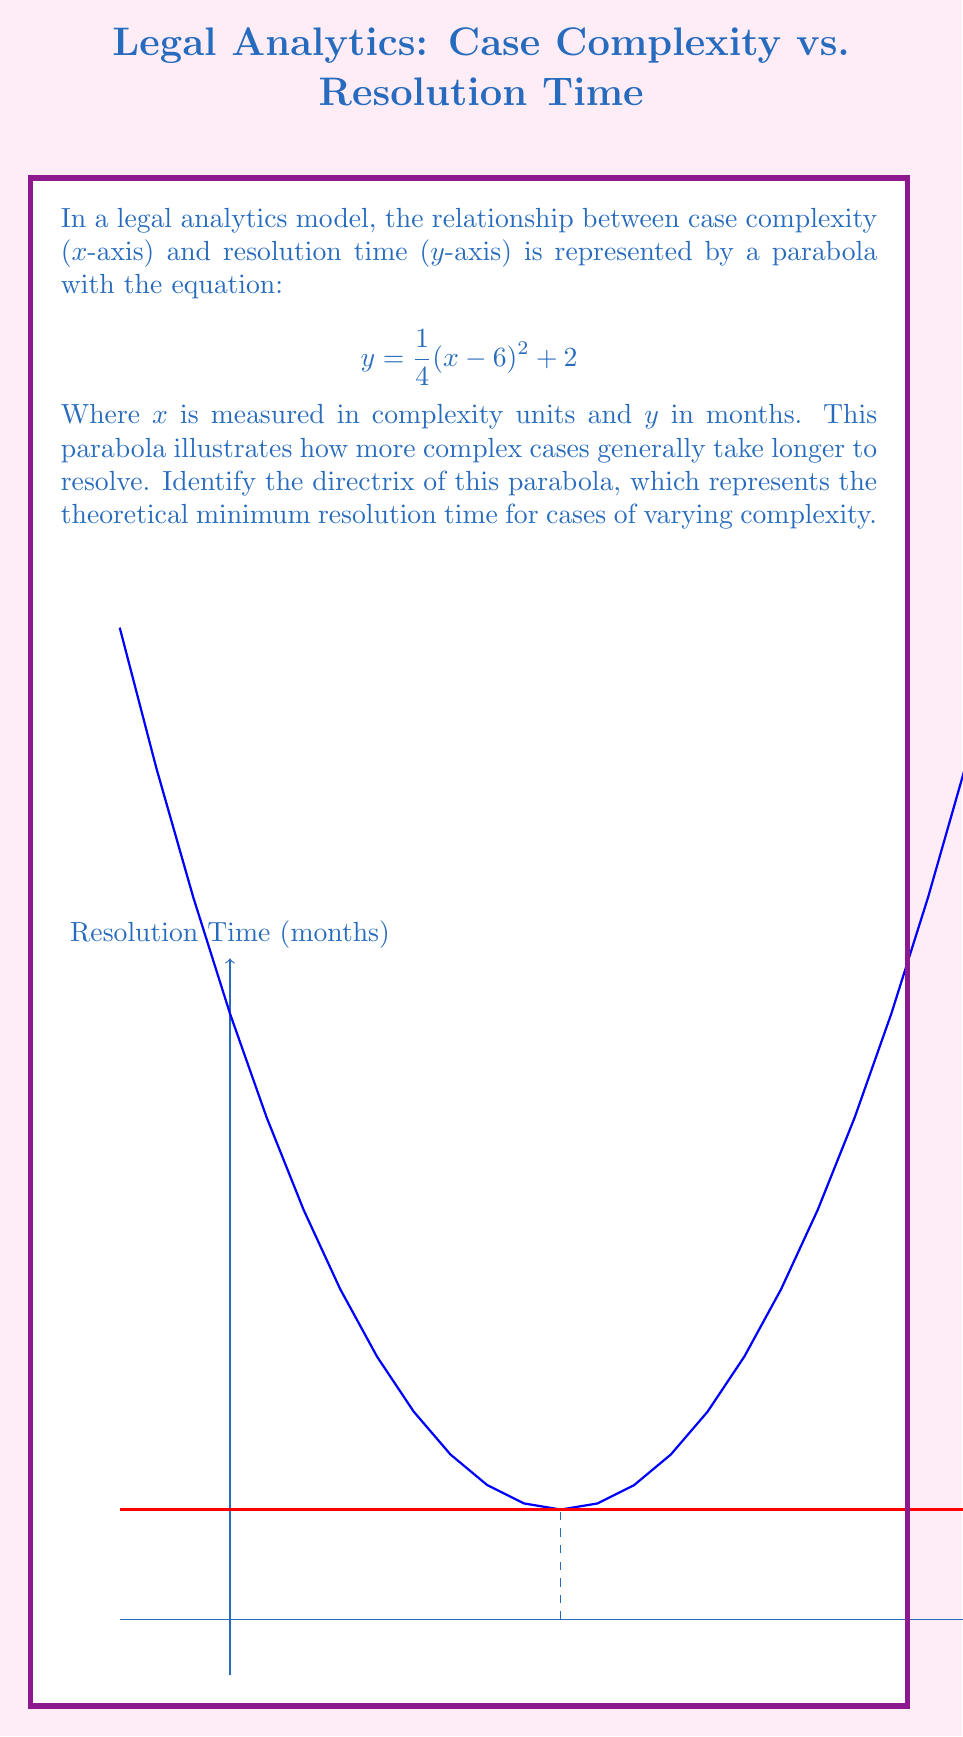Can you answer this question? To find the directrix of the parabola, we'll follow these steps:

1) The general form of a parabola with a vertical axis of symmetry is:
   $$ y = a(x - h)^2 + k $$
   where (h, k) is the vertex and a determines the direction and width of the parabola.

2) Comparing our equation to the general form:
   $$ y = \frac{1}{4}(x - 6)^2 + 2 $$
   We can identify that $a = \frac{1}{4}$, $h = 6$, and $k = 2$.

3) The vertex of the parabola is (6, 2).

4) For a parabola with a vertical axis of symmetry, the distance from the vertex to the directrix is given by $\frac{1}{4a}$.

5) Calculate this distance:
   $$ \frac{1}{4a} = \frac{1}{4(\frac{1}{4})} = 1 $$

6) Since the parabola opens upward (a > 0), the directrix is 1 unit below the vertex.

7) Therefore, the y-coordinate of the directrix is:
   $$ y = 2 - 1 = 1 $$

8) The directrix is a horizontal line, so its equation is y = 1.

In the context of the legal model, this means the theoretical minimum resolution time for cases of any complexity is 1 month.
Answer: $y = 1$ 